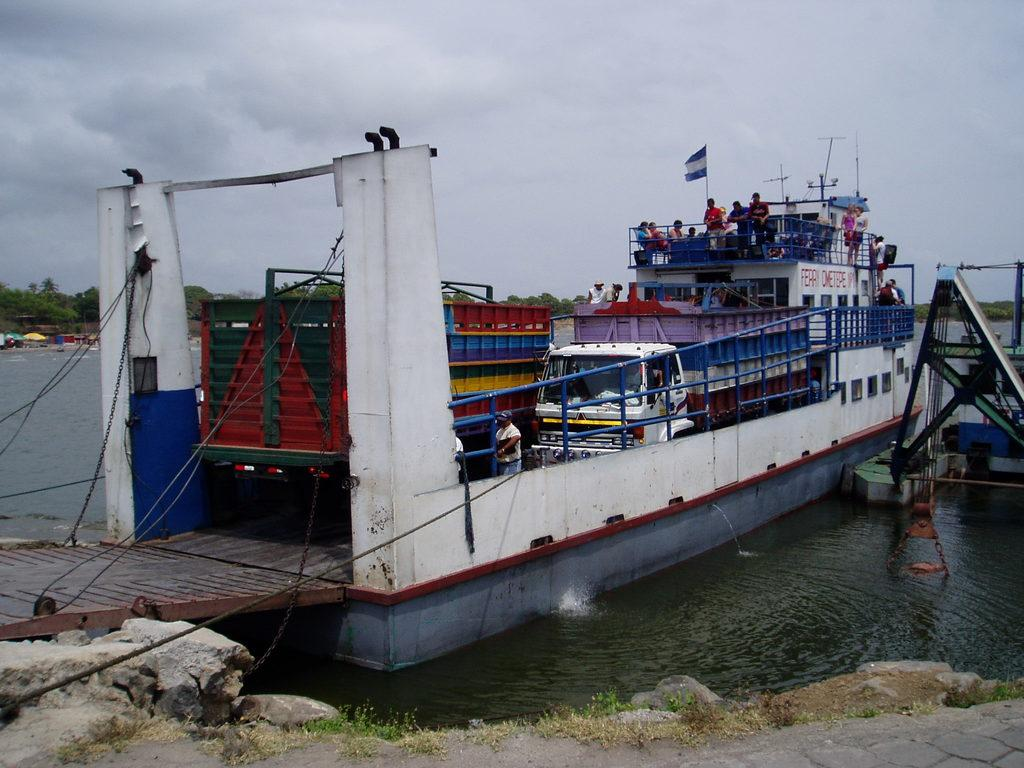What is the main subject of the image? The main subject of the image is a ship. What can be seen on the ship? There are two vehicles and people on the ship. Where is the ship located? The ship is on the water surface. How many apples are being carried in the basket on the ship? There is no basket or apple present on the ship in the image. 